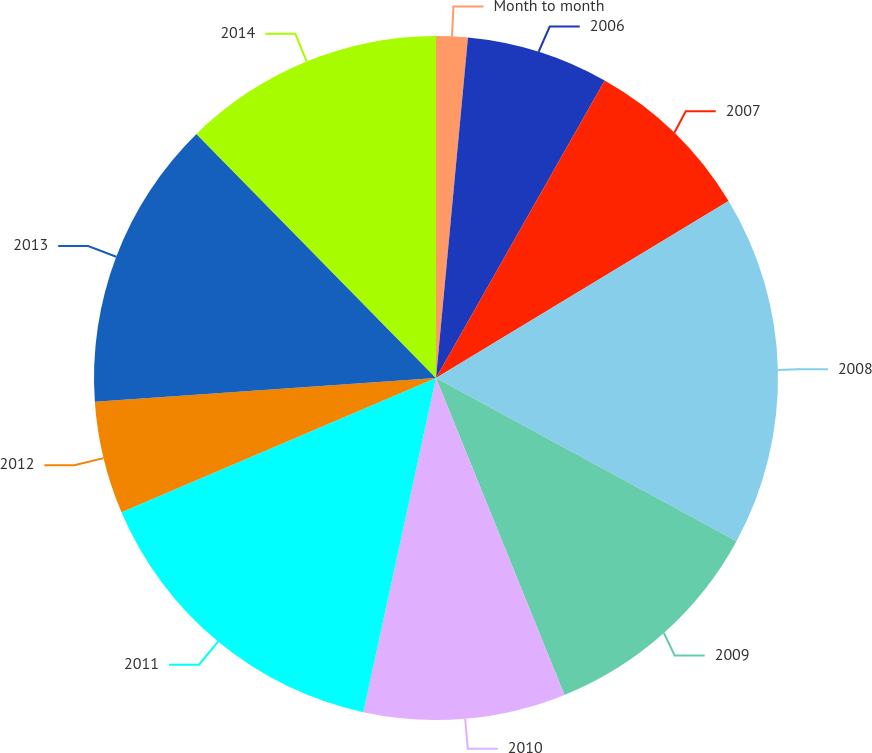Convert chart to OTSL. <chart><loc_0><loc_0><loc_500><loc_500><pie_chart><fcel>Month to month<fcel>2006<fcel>2007<fcel>2008<fcel>2009<fcel>2010<fcel>2011<fcel>2012<fcel>2013<fcel>2014<nl><fcel>1.49%<fcel>6.72%<fcel>8.13%<fcel>16.58%<fcel>10.95%<fcel>9.54%<fcel>15.17%<fcel>5.31%<fcel>13.76%<fcel>12.35%<nl></chart> 